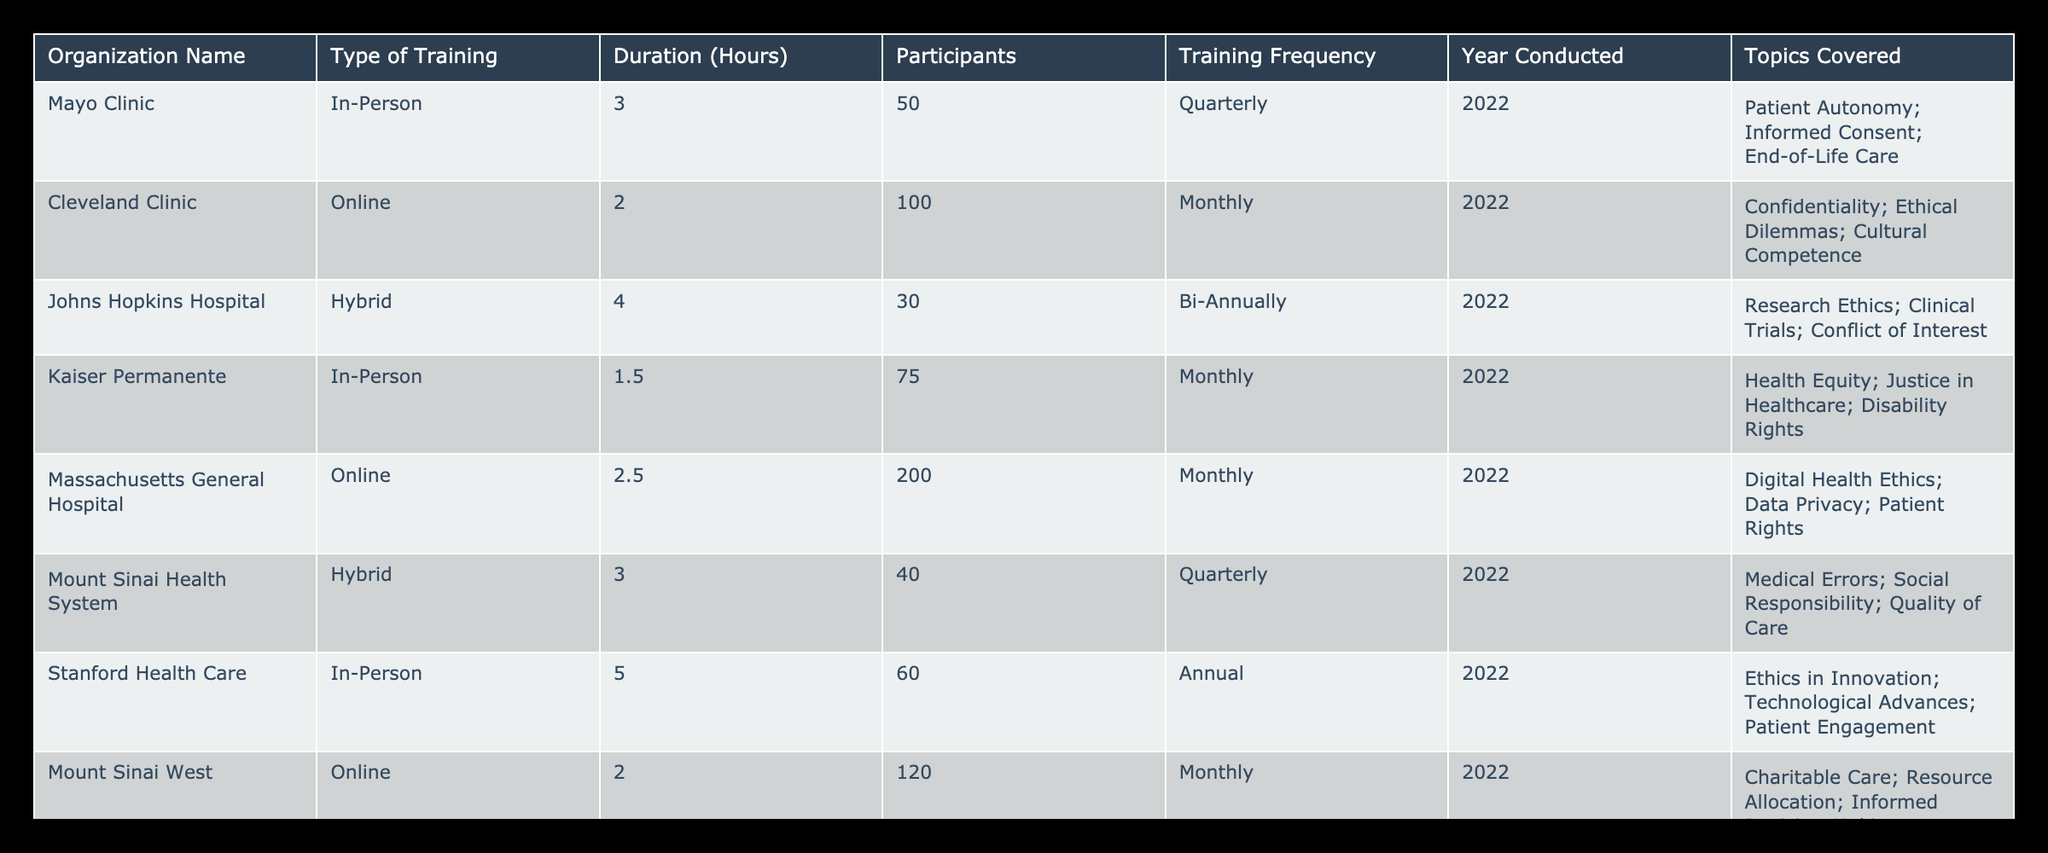What is the longest duration of training offered among these organizations? The table indicates various training durations. Scanning through the "Duration (Hours)" column, we find Mayo Clinic at 3 hours, Cleveland Clinic at 2 hours, Johns Hopkins Hospital at 4 hours, Kaiser Permanente at 1.5 hours, Massachusetts General Hospital at 2.5 hours, Mount Sinai Health System at 3 hours, Stanford Health Care at 5 hours, and Mount Sinai West at 2 hours. The highest duration is 5 hours offered by Stanford Health Care.
Answer: 5 hours How many participants attended the training sessions at Massachusetts General Hospital? Looking at the "Participants" column, Massachusetts General Hospital is listed with 200 participants attending their training sessions.
Answer: 200 What percentage of training sessions were conducted online? There are a total of 8 training sessions listed. The online sessions include Cleveland Clinic, Massachusetts General Hospital, and Mount Sinai West, totaling 3 online sessions. To find the percentage, we divide 3 online sessions by 8 total sessions and then multiply by 100, resulting in 37.5%.
Answer: 37.5% Did Kaiser Permanente offer training in "Patient Engagement"? Checking the "Topics Covered" column for Kaiser Permanente, the topics listed include Health Equity, Justice in Healthcare, and Disability Rights, but "Patient Engagement" is not one of them. Thus, the answer is no.
Answer: No What is the average number of participants across all organizations for the training sessions? First, we total the number of participants from each organization: 50 (Mayo Clinic) + 100 (Cleveland Clinic) + 30 (Johns Hopkins) + 75 (Kaiser Permanente) + 200 (Massachusetts General) + 40 (Mount Sinai) + 60 (Stanford) + 120 (Mount Sinai West) equals 675 participants. There are 8 organizations, so we then calculate the average by dividing the total participants (675) by the number of organizations (8), which is 84.375 participants.
Answer: 84.375 Which organization had the highest frequency of training sessions? The "Training Frequency" column shows that Kaiser Permanente, Massachusetts General Hospital, and Mount Sinai West offer training sessions monthly. The others have a lower frequency: Mayo and Mount Sinai Health monthly, Johns Hopkins bi-annually, and Stanford annually. Thus, multiple organizations had the top frequency, but Kaiser Permanente had monthly sessions notably with a count of 75 participants.
Answer: Multiple organizations having monthly sessions, highest relative to participants Kaiser Permanente 